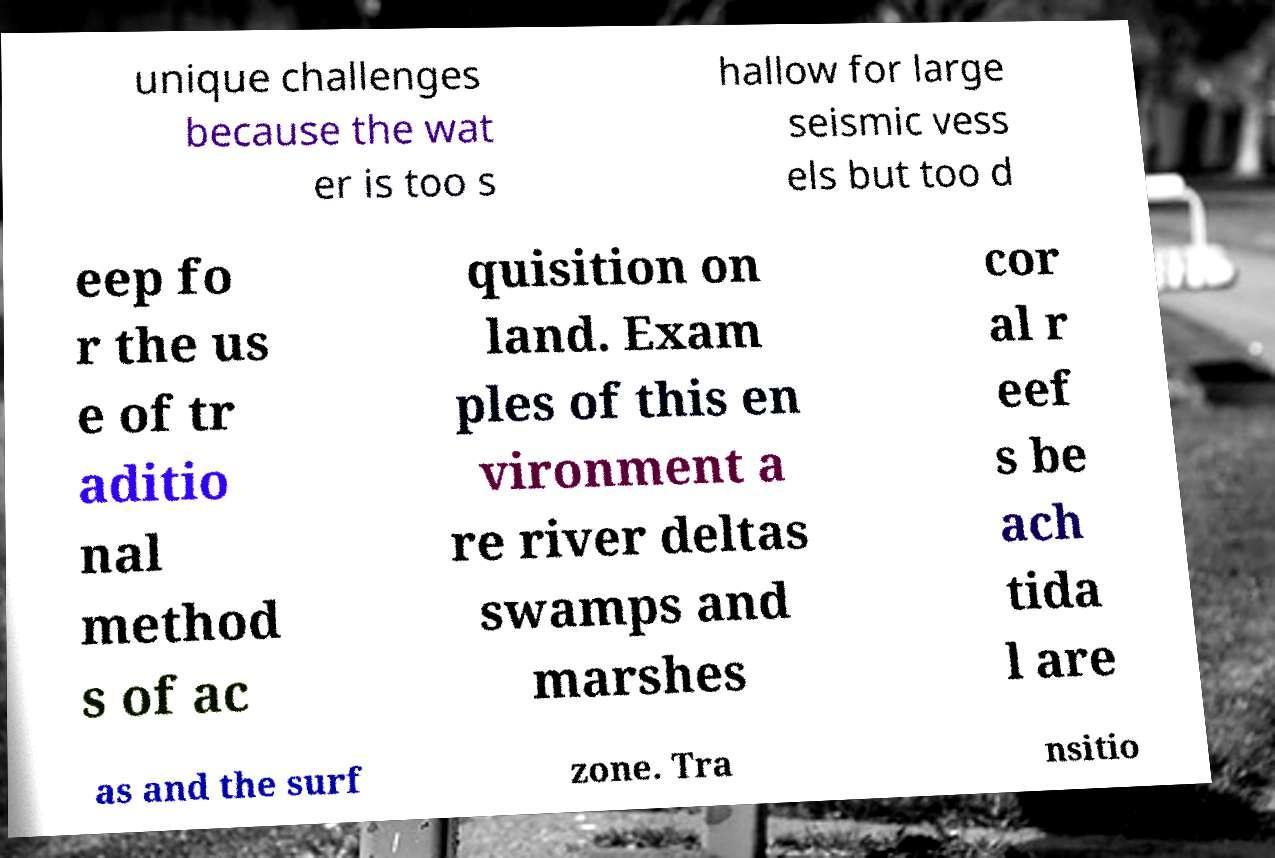Could you extract and type out the text from this image? unique challenges because the wat er is too s hallow for large seismic vess els but too d eep fo r the us e of tr aditio nal method s of ac quisition on land. Exam ples of this en vironment a re river deltas swamps and marshes cor al r eef s be ach tida l are as and the surf zone. Tra nsitio 